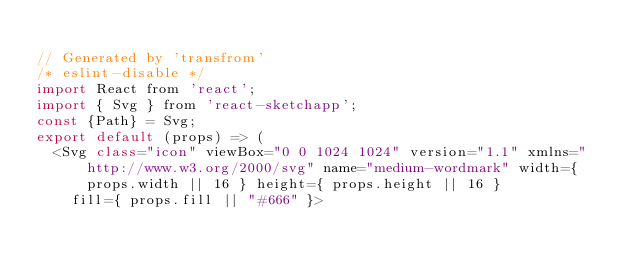<code> <loc_0><loc_0><loc_500><loc_500><_JavaScript_>
// Generated by 'transfrom'
/* eslint-disable */
import React from 'react';
import { Svg } from 'react-sketchapp';
const {Path} = Svg;
export default (props) => (
  <Svg class="icon" viewBox="0 0 1024 1024" version="1.1" xmlns="http://www.w3.org/2000/svg" name="medium-wordmark" width={ props.width || 16 } height={ props.height || 16 }
    fill={ props.fill || "#666" }></code> 